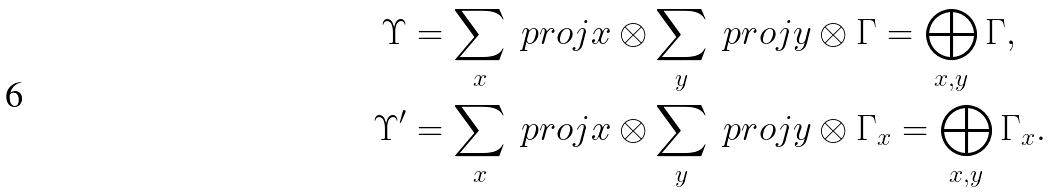<formula> <loc_0><loc_0><loc_500><loc_500>\Upsilon & = \sum _ { x } \ p r o j { x } \otimes \sum _ { y } \ p r o j { y } \otimes \Gamma = \bigoplus _ { x , y } \Gamma , \\ \Upsilon ^ { \prime } & = \sum _ { x } \ p r o j { x } \otimes \sum _ { y } \ p r o j { y } \otimes \Gamma _ { x } = \bigoplus _ { x , y } \Gamma _ { x } .</formula> 